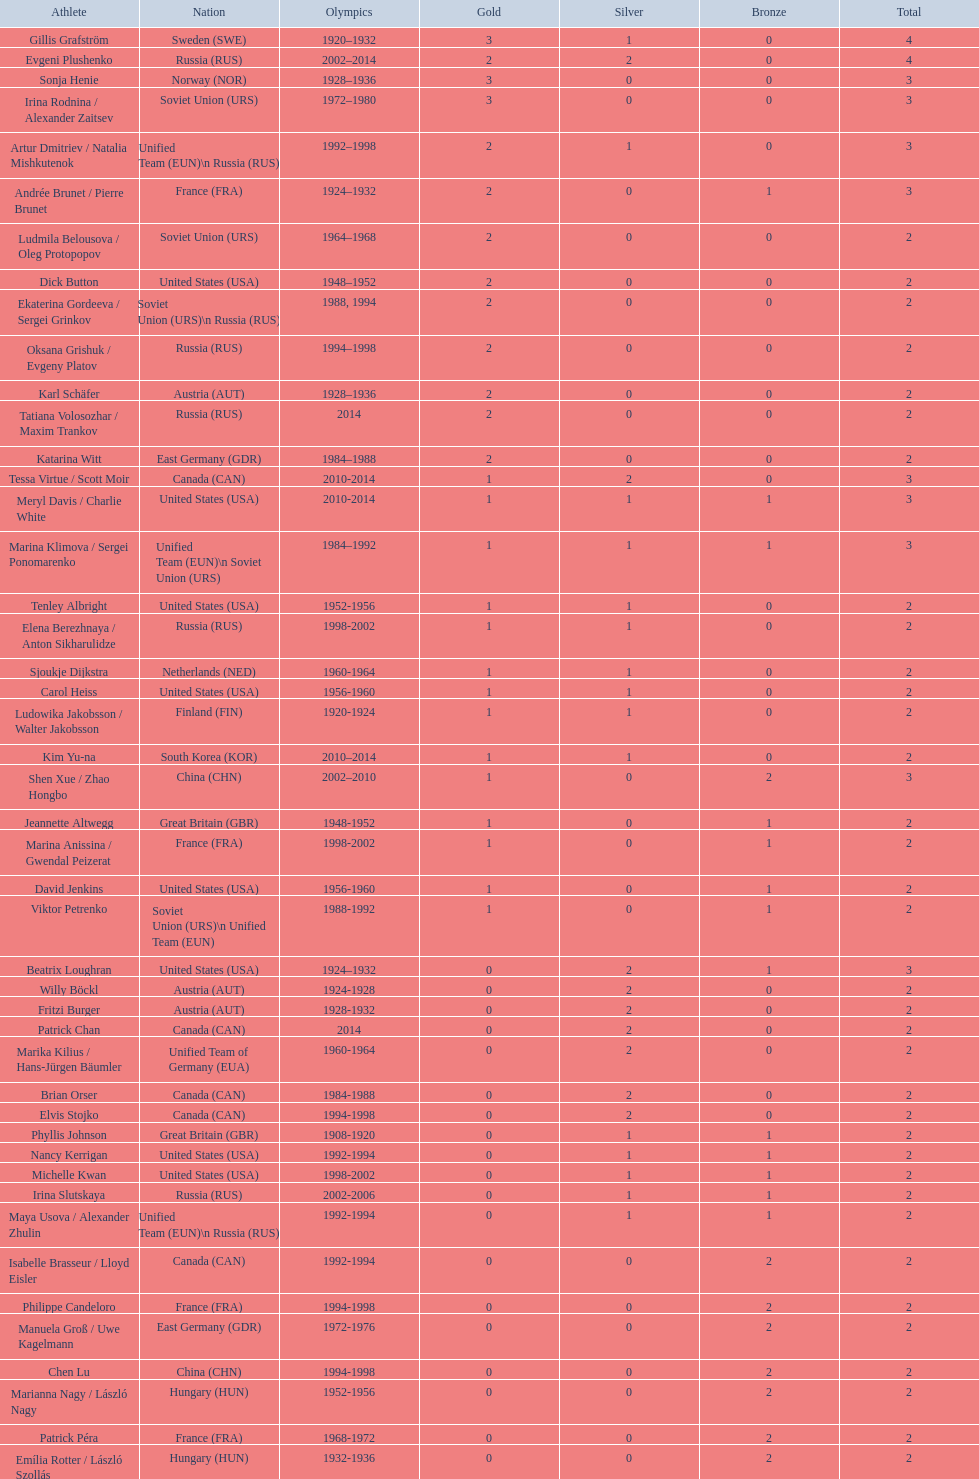What is the total number of medals won by the united states in women's figure skating? 16. 